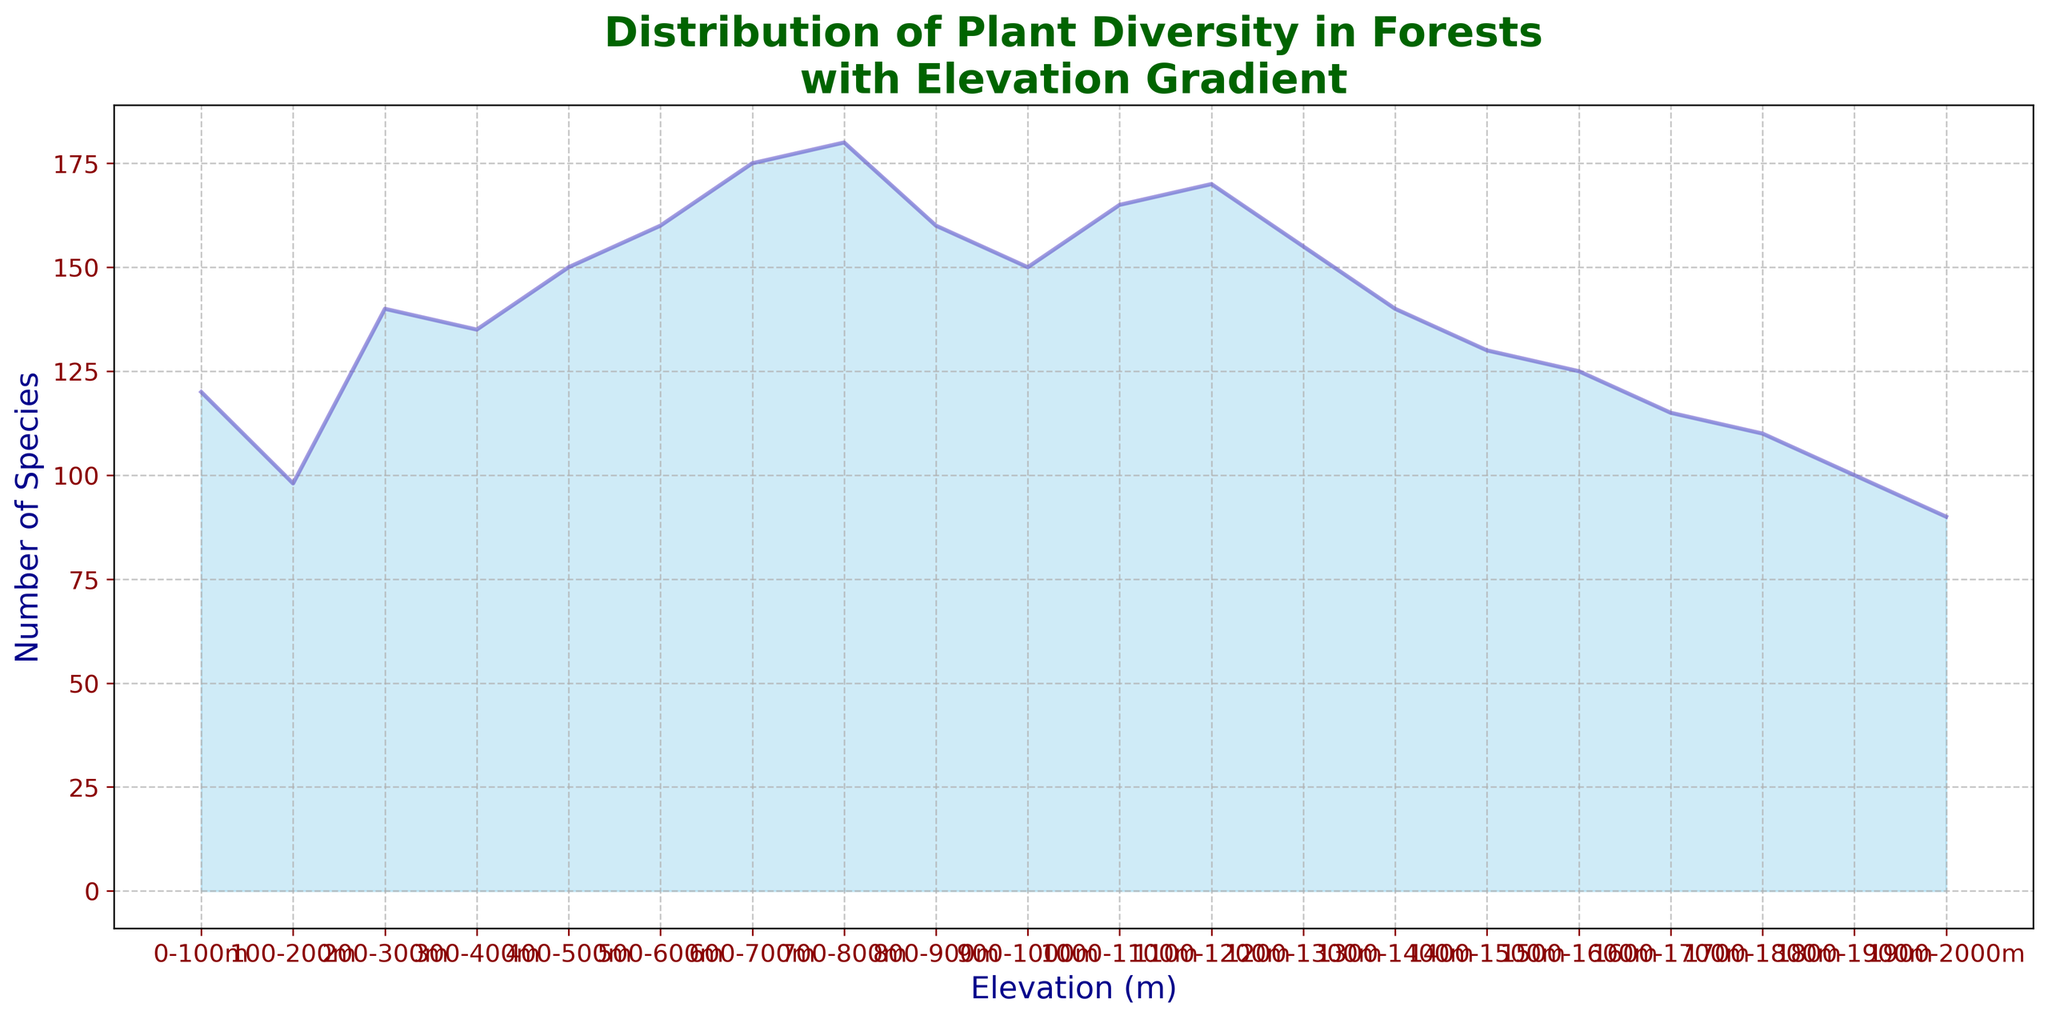What is the highest number of species observed? By visually inspecting the peaks of the area chart, you can determine that the highest peak corresponds to 180 species between 700-800m elevation.
Answer: 180 How does the number of species change from 1000-1100m to 1200-1300m? First, note the number of species at 1000-1100m is 165 and at 1200-1300m is 155. The change is calculated as 165 - 155 = 10 species decrease.
Answer: Decreases by 10 Which elevation range has the lowest number of species? By examining the troughs of the area chart, identify that the lowest point is at 1900-2000m, corresponding to 90 species.
Answer: 1900-2000m Is the number of species at 1300-1400m more or less than the number of species at 300-400m? Compare the number of species in both ranges directly from the chart. At 1300-1400m, there are 140 species, while at 300-400m, there are 135 species. Hence, 1300-1400m has more species.
Answer: More What is the average number of species between 600-800m? Calculate the average by summing the number of species in the 600-700m and 700-800m elevations and then dividing by 2. (175 + 180) / 2 = 177.5
Answer: 177.5 By how much do the number of species decrease from 500-600m to 0-100m? Determine the number of species at both elevations, then subtract the lower elevation value from the higher one: 160 - 120 = 40 species.
Answer: 40 What is the trend in species diversity as elevation increases from 0-100m to 600-700m? Observe the area chart to see how the number of species changes with increasing elevation. The number of species initially decreases and then steadily increases, peaking at 700-800m.
Answer: Initially decreases, then increases From 1300-1400m to 1500-1600m, how significant is the change in species diversity? Calculate the difference in the number of species: 140 - 125 = 15 species. Thus, the decrease is by 15 species.
Answer: Decreases by 15 At which elevation range do we start to see a general decline in the number of species? Visually analyze the area chart to pinpoint where the decline starts. The decline starts after the peak at 700-800m, beginning from 800-900m.
Answer: 800-900m 